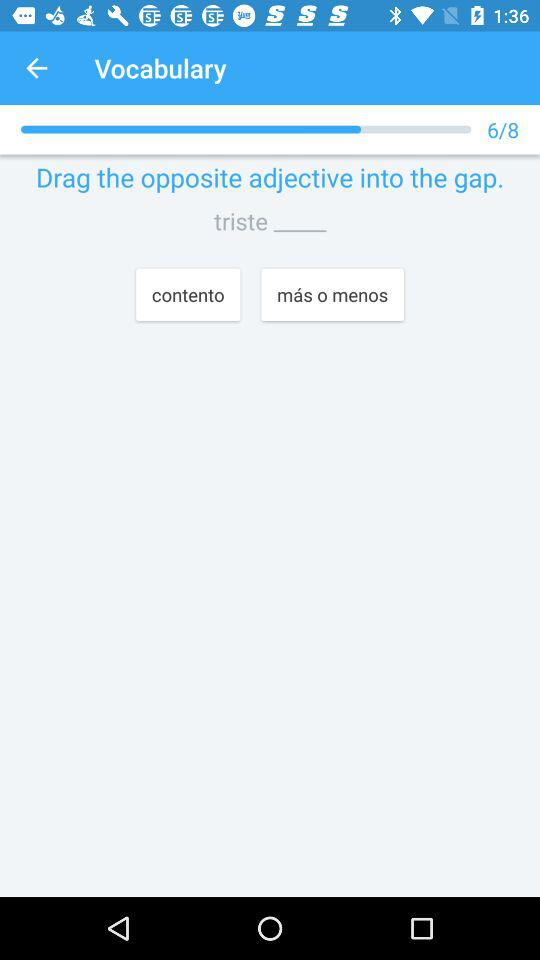How many questions in total are there? There are 8 questions in total. 